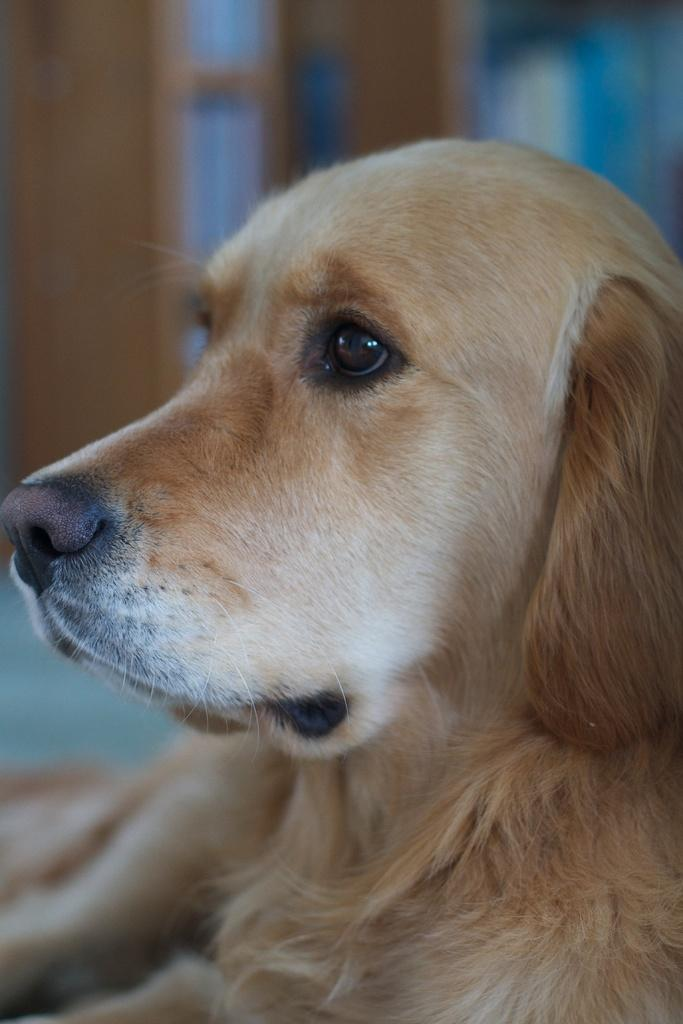What type of animal is present in the image? There is a dog in the image. What type of texture can be seen on the dog's food in the image? There is no dog food present in the image, and therefore no texture can be observed. 